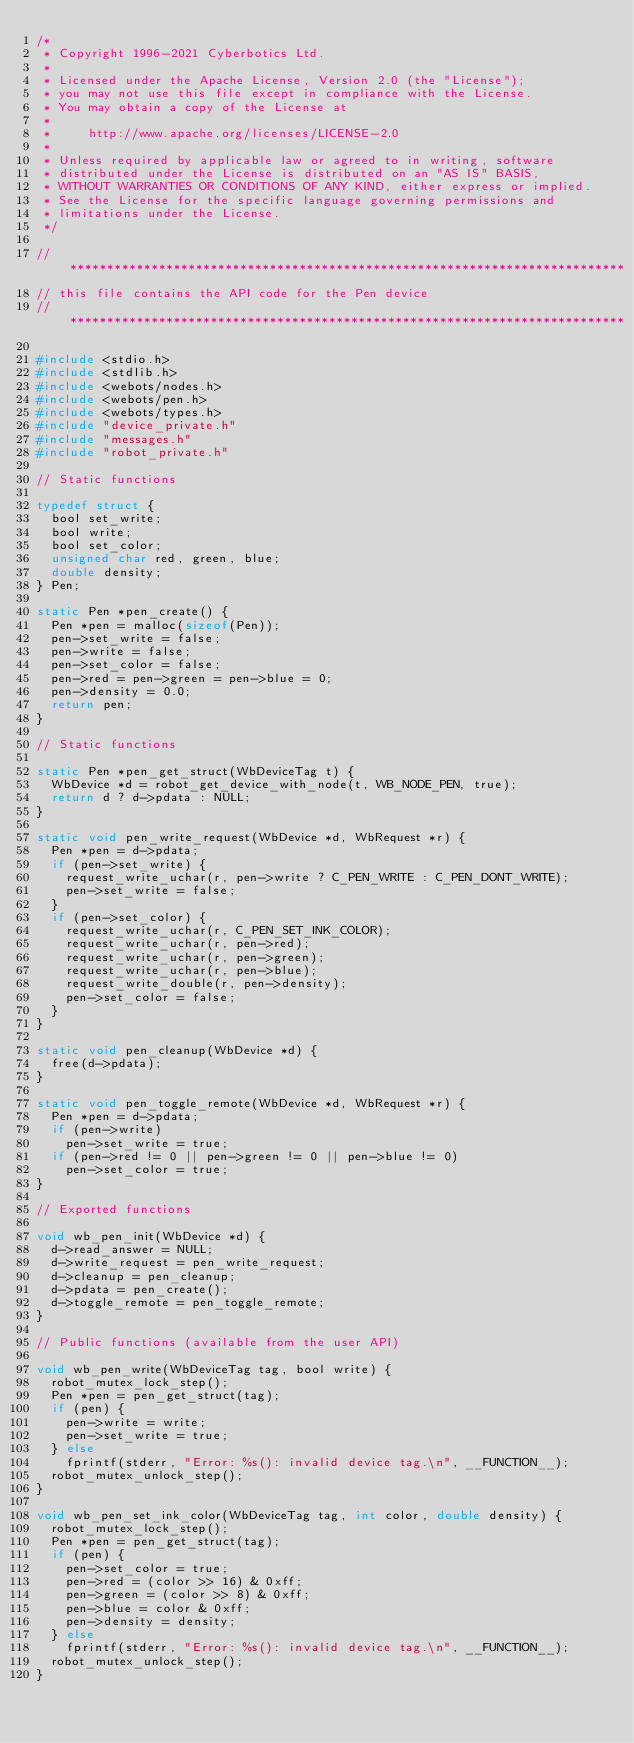<code> <loc_0><loc_0><loc_500><loc_500><_C_>/*
 * Copyright 1996-2021 Cyberbotics Ltd.
 *
 * Licensed under the Apache License, Version 2.0 (the "License");
 * you may not use this file except in compliance with the License.
 * You may obtain a copy of the License at
 *
 *     http://www.apache.org/licenses/LICENSE-2.0
 *
 * Unless required by applicable law or agreed to in writing, software
 * distributed under the License is distributed on an "AS IS" BASIS,
 * WITHOUT WARRANTIES OR CONDITIONS OF ANY KIND, either express or implied.
 * See the License for the specific language governing permissions and
 * limitations under the License.
 */

// ***************************************************************************
// this file contains the API code for the Pen device
// ***************************************************************************

#include <stdio.h>
#include <stdlib.h>
#include <webots/nodes.h>
#include <webots/pen.h>
#include <webots/types.h>
#include "device_private.h"
#include "messages.h"
#include "robot_private.h"

// Static functions

typedef struct {
  bool set_write;
  bool write;
  bool set_color;
  unsigned char red, green, blue;
  double density;
} Pen;

static Pen *pen_create() {
  Pen *pen = malloc(sizeof(Pen));
  pen->set_write = false;
  pen->write = false;
  pen->set_color = false;
  pen->red = pen->green = pen->blue = 0;
  pen->density = 0.0;
  return pen;
}

// Static functions

static Pen *pen_get_struct(WbDeviceTag t) {
  WbDevice *d = robot_get_device_with_node(t, WB_NODE_PEN, true);
  return d ? d->pdata : NULL;
}

static void pen_write_request(WbDevice *d, WbRequest *r) {
  Pen *pen = d->pdata;
  if (pen->set_write) {
    request_write_uchar(r, pen->write ? C_PEN_WRITE : C_PEN_DONT_WRITE);
    pen->set_write = false;
  }
  if (pen->set_color) {
    request_write_uchar(r, C_PEN_SET_INK_COLOR);
    request_write_uchar(r, pen->red);
    request_write_uchar(r, pen->green);
    request_write_uchar(r, pen->blue);
    request_write_double(r, pen->density);
    pen->set_color = false;
  }
}

static void pen_cleanup(WbDevice *d) {
  free(d->pdata);
}

static void pen_toggle_remote(WbDevice *d, WbRequest *r) {
  Pen *pen = d->pdata;
  if (pen->write)
    pen->set_write = true;
  if (pen->red != 0 || pen->green != 0 || pen->blue != 0)
    pen->set_color = true;
}

// Exported functions

void wb_pen_init(WbDevice *d) {
  d->read_answer = NULL;
  d->write_request = pen_write_request;
  d->cleanup = pen_cleanup;
  d->pdata = pen_create();
  d->toggle_remote = pen_toggle_remote;
}

// Public functions (available from the user API)

void wb_pen_write(WbDeviceTag tag, bool write) {
  robot_mutex_lock_step();
  Pen *pen = pen_get_struct(tag);
  if (pen) {
    pen->write = write;
    pen->set_write = true;
  } else
    fprintf(stderr, "Error: %s(): invalid device tag.\n", __FUNCTION__);
  robot_mutex_unlock_step();
}

void wb_pen_set_ink_color(WbDeviceTag tag, int color, double density) {
  robot_mutex_lock_step();
  Pen *pen = pen_get_struct(tag);
  if (pen) {
    pen->set_color = true;
    pen->red = (color >> 16) & 0xff;
    pen->green = (color >> 8) & 0xff;
    pen->blue = color & 0xff;
    pen->density = density;
  } else
    fprintf(stderr, "Error: %s(): invalid device tag.\n", __FUNCTION__);
  robot_mutex_unlock_step();
}
</code> 